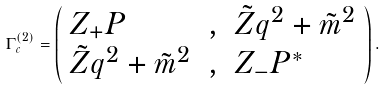Convert formula to latex. <formula><loc_0><loc_0><loc_500><loc_500>\Gamma ^ { ( 2 ) } _ { c } = \left ( \begin{array} { l l l } Z _ { + } P & , & \tilde { Z } q ^ { 2 } + \tilde { m } ^ { 2 } \\ \tilde { Z } q ^ { 2 } + \tilde { m } ^ { 2 } & , & Z _ { - } P ^ { * } \end{array} \right ) .</formula> 